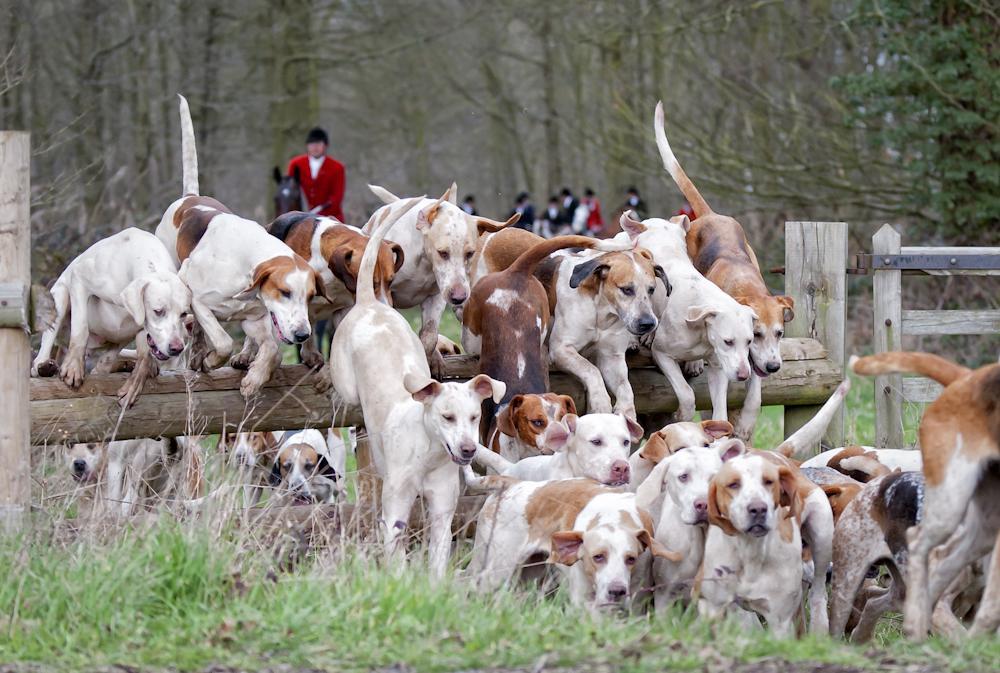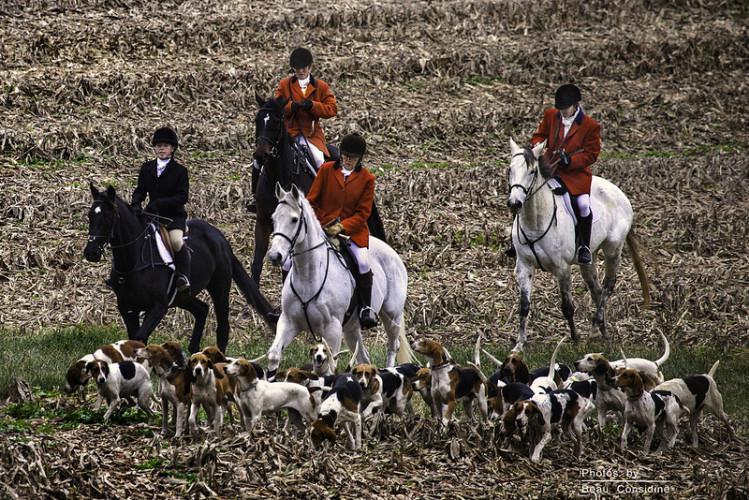The first image is the image on the left, the second image is the image on the right. Considering the images on both sides, is "Each image includes at least one horse and multiple beagles, and at least one image includes a rider wearing red." valid? Answer yes or no. Yes. The first image is the image on the left, the second image is the image on the right. For the images displayed, is the sentence "People in coats are riding horses with several dogs in the image on the left." factually correct? Answer yes or no. Yes. 